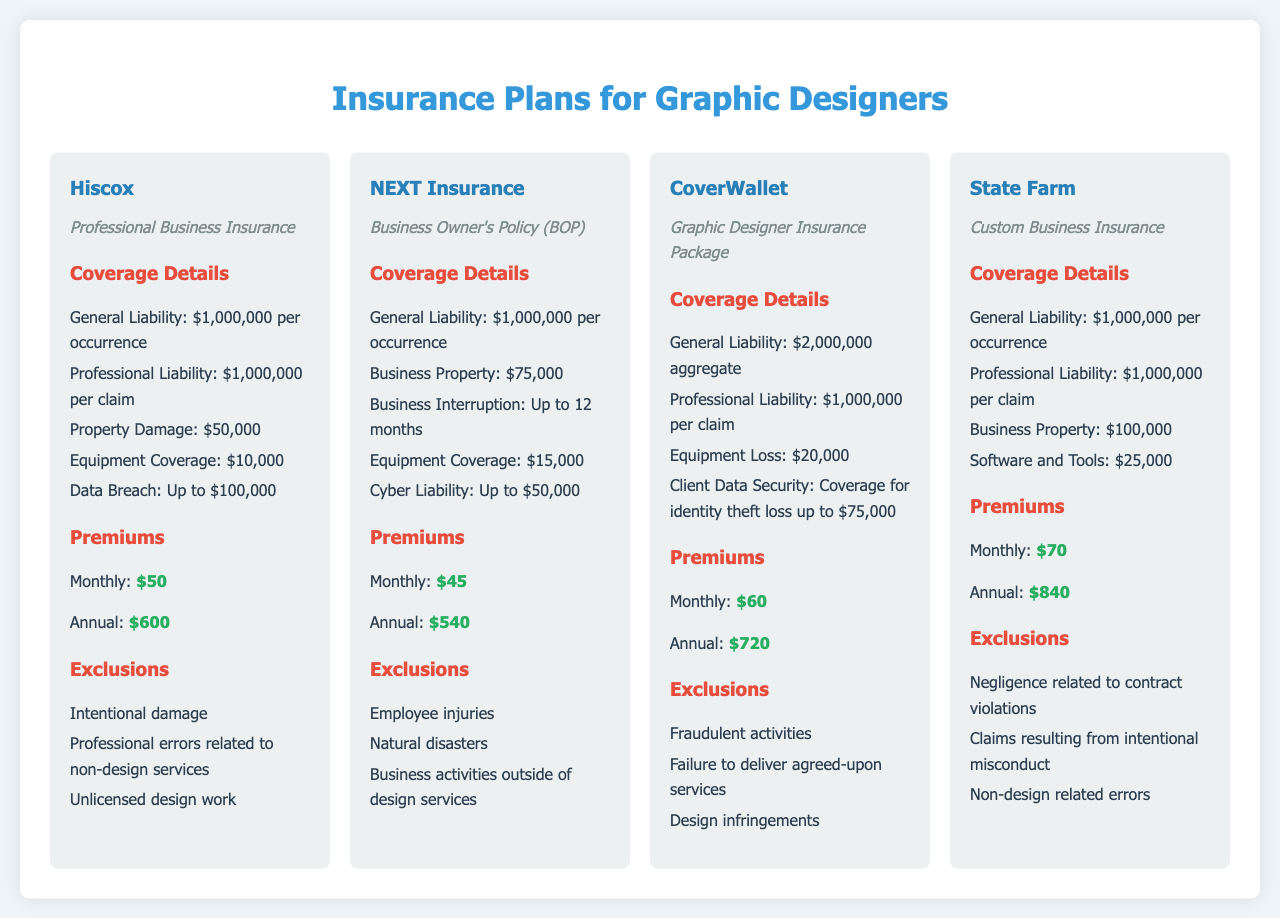What is the coverage amount for General Liability with Hiscox? Hiscox offers a General Liability coverage of $1,000,000 per occurrence, as stated in the coverage details section.
Answer: $1,000,000 per occurrence What is the monthly premium for NEXT Insurance? NEXT Insurance charges a monthly premium of $45, as mentioned under the Premiums section.
Answer: $45 How much Equipment Coverage does CoverWallet provide? CoverWallet provides Equipment Loss coverage of $20,000, which is indicated in the coverage details.
Answer: $20,000 What types of exclusions does State Farm list? State Farm lists exclusions such as negligence related to contract violations and intentional misconduct, per the exclusions section.
Answer: Negligence related to contract violations, claims resulting from intentional misconduct, non-design related errors Which insurance plan offers the highest General Liability coverage? CoverWallet offers the highest General Liability coverage with an aggregate limit of $2,000,000, as compared to others.
Answer: $2,000,000 aggregate What is the annual premium for Hiscox? The annual premium for Hiscox is mentioned as $600 under the Premiums section.
Answer: $600 How much Cyber Liability coverage does NEXT Insurance provide? NEXT Insurance provides Cyber Liability coverage of up to $50,000, according to the coverage details.
Answer: Up to $50,000 What insurance plan has exclusions related to "Fraudulent activities"? The exclusions related to "Fraudulent activities" are specified under CoverWallet's plan.
Answer: CoverWallet 